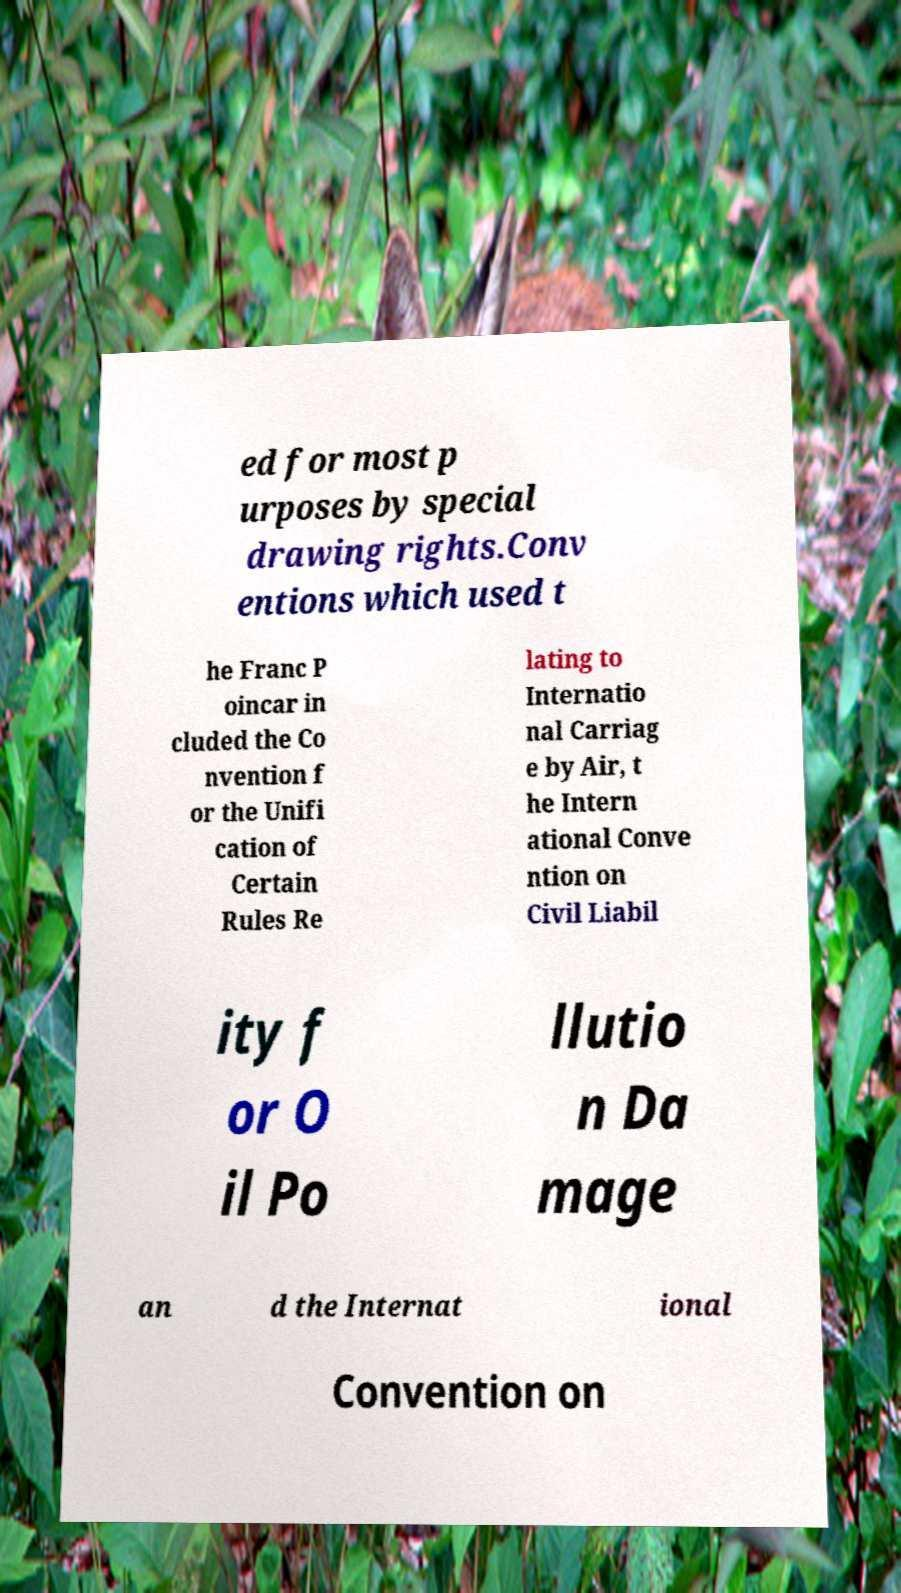There's text embedded in this image that I need extracted. Can you transcribe it verbatim? ed for most p urposes by special drawing rights.Conv entions which used t he Franc P oincar in cluded the Co nvention f or the Unifi cation of Certain Rules Re lating to Internatio nal Carriag e by Air, t he Intern ational Conve ntion on Civil Liabil ity f or O il Po llutio n Da mage an d the Internat ional Convention on 